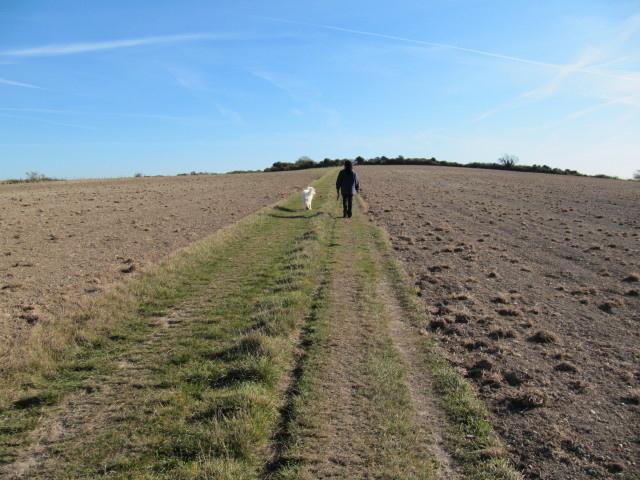Is there a crop in the field?
Be succinct. No. How many people are pictured?
Be succinct. 1. What color is the dog?
Be succinct. White. Is it probably cold out?
Keep it brief. No. Can you see the boys shadow?
Concise answer only. Yes. What is traveling by the animals?
Concise answer only. Person. IS this taken from the street?
Answer briefly. No. What time of year is it?
Be succinct. Spring. 